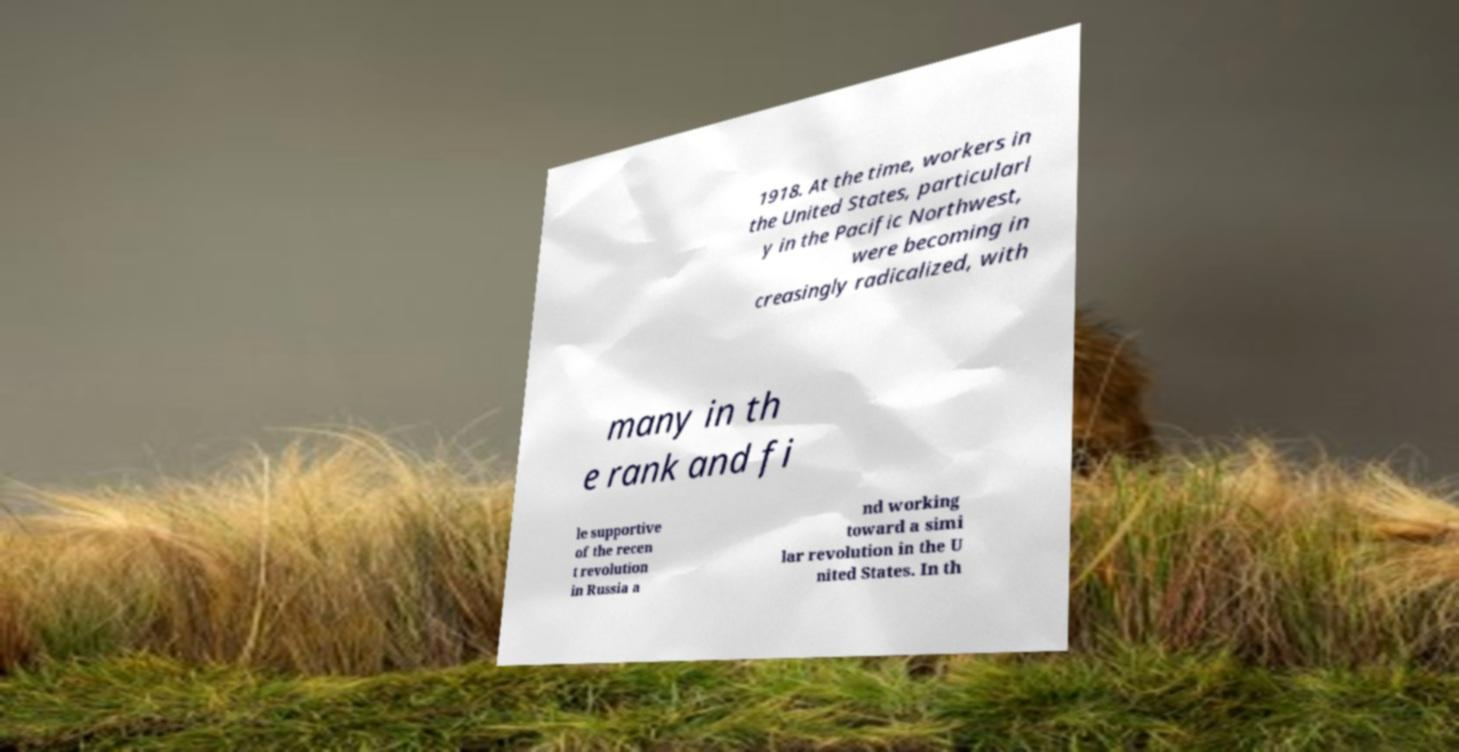For documentation purposes, I need the text within this image transcribed. Could you provide that? 1918. At the time, workers in the United States, particularl y in the Pacific Northwest, were becoming in creasingly radicalized, with many in th e rank and fi le supportive of the recen t revolution in Russia a nd working toward a simi lar revolution in the U nited States. In th 